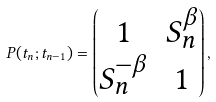Convert formula to latex. <formula><loc_0><loc_0><loc_500><loc_500>P ( t _ { n } ; t _ { n - 1 } ) = \begin{pmatrix} 1 & S _ { n } ^ { \beta } \\ S _ { n } ^ { - \beta } & 1 \end{pmatrix} ,</formula> 